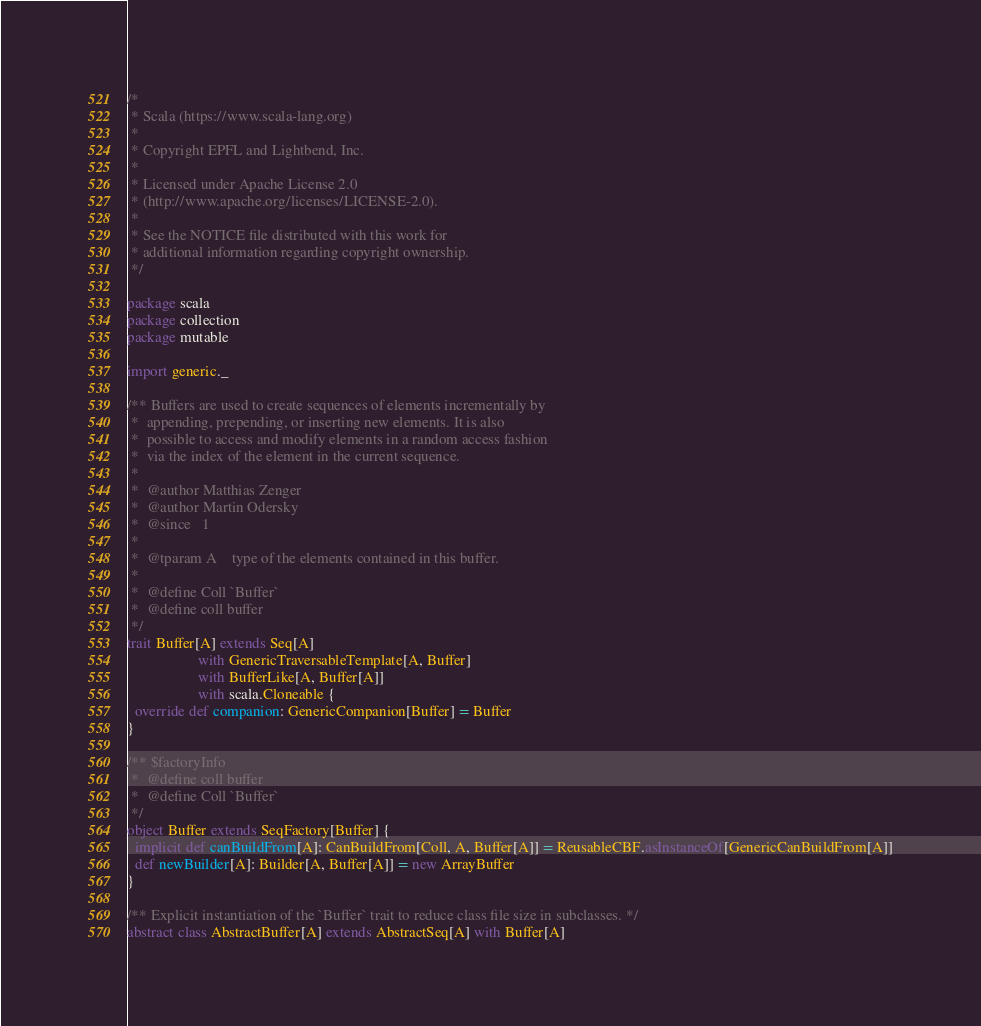Convert code to text. <code><loc_0><loc_0><loc_500><loc_500><_Scala_>/*
 * Scala (https://www.scala-lang.org)
 *
 * Copyright EPFL and Lightbend, Inc.
 *
 * Licensed under Apache License 2.0
 * (http://www.apache.org/licenses/LICENSE-2.0).
 *
 * See the NOTICE file distributed with this work for
 * additional information regarding copyright ownership.
 */

package scala
package collection
package mutable

import generic._

/** Buffers are used to create sequences of elements incrementally by
 *  appending, prepending, or inserting new elements. It is also
 *  possible to access and modify elements in a random access fashion
 *  via the index of the element in the current sequence.
 *
 *  @author Matthias Zenger
 *  @author Martin Odersky
 *  @since   1
 *
 *  @tparam A    type of the elements contained in this buffer.
 *
 *  @define Coll `Buffer`
 *  @define coll buffer
 */
trait Buffer[A] extends Seq[A]
                   with GenericTraversableTemplate[A, Buffer]
                   with BufferLike[A, Buffer[A]]
                   with scala.Cloneable {
  override def companion: GenericCompanion[Buffer] = Buffer
}

/** $factoryInfo
 *  @define coll buffer
 *  @define Coll `Buffer`
 */
object Buffer extends SeqFactory[Buffer] {
  implicit def canBuildFrom[A]: CanBuildFrom[Coll, A, Buffer[A]] = ReusableCBF.asInstanceOf[GenericCanBuildFrom[A]]
  def newBuilder[A]: Builder[A, Buffer[A]] = new ArrayBuffer
}

/** Explicit instantiation of the `Buffer` trait to reduce class file size in subclasses. */
abstract class AbstractBuffer[A] extends AbstractSeq[A] with Buffer[A]
</code> 